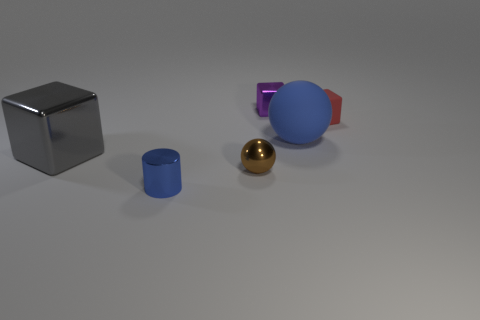There is a small cube in front of the small thing that is behind the tiny red rubber object; is there a brown thing behind it?
Keep it short and to the point. No. Is the color of the large matte ball the same as the small thing that is on the right side of the tiny shiny block?
Make the answer very short. No. What number of cubes are the same color as the big matte thing?
Give a very brief answer. 0. There is a cube that is in front of the small block right of the purple thing; how big is it?
Provide a short and direct response. Large. How many things are metal things behind the big blue sphere or metallic balls?
Your answer should be compact. 2. Is there a yellow metal thing of the same size as the brown metallic sphere?
Provide a succinct answer. No. Are there any metal blocks that are behind the big gray metal block in front of the blue matte ball?
Your answer should be compact. Yes. What number of balls are either brown metallic objects or gray things?
Ensure brevity in your answer.  1. Is there a brown metal thing that has the same shape as the big gray metal object?
Provide a succinct answer. No. What is the shape of the small brown thing?
Offer a very short reply. Sphere. 